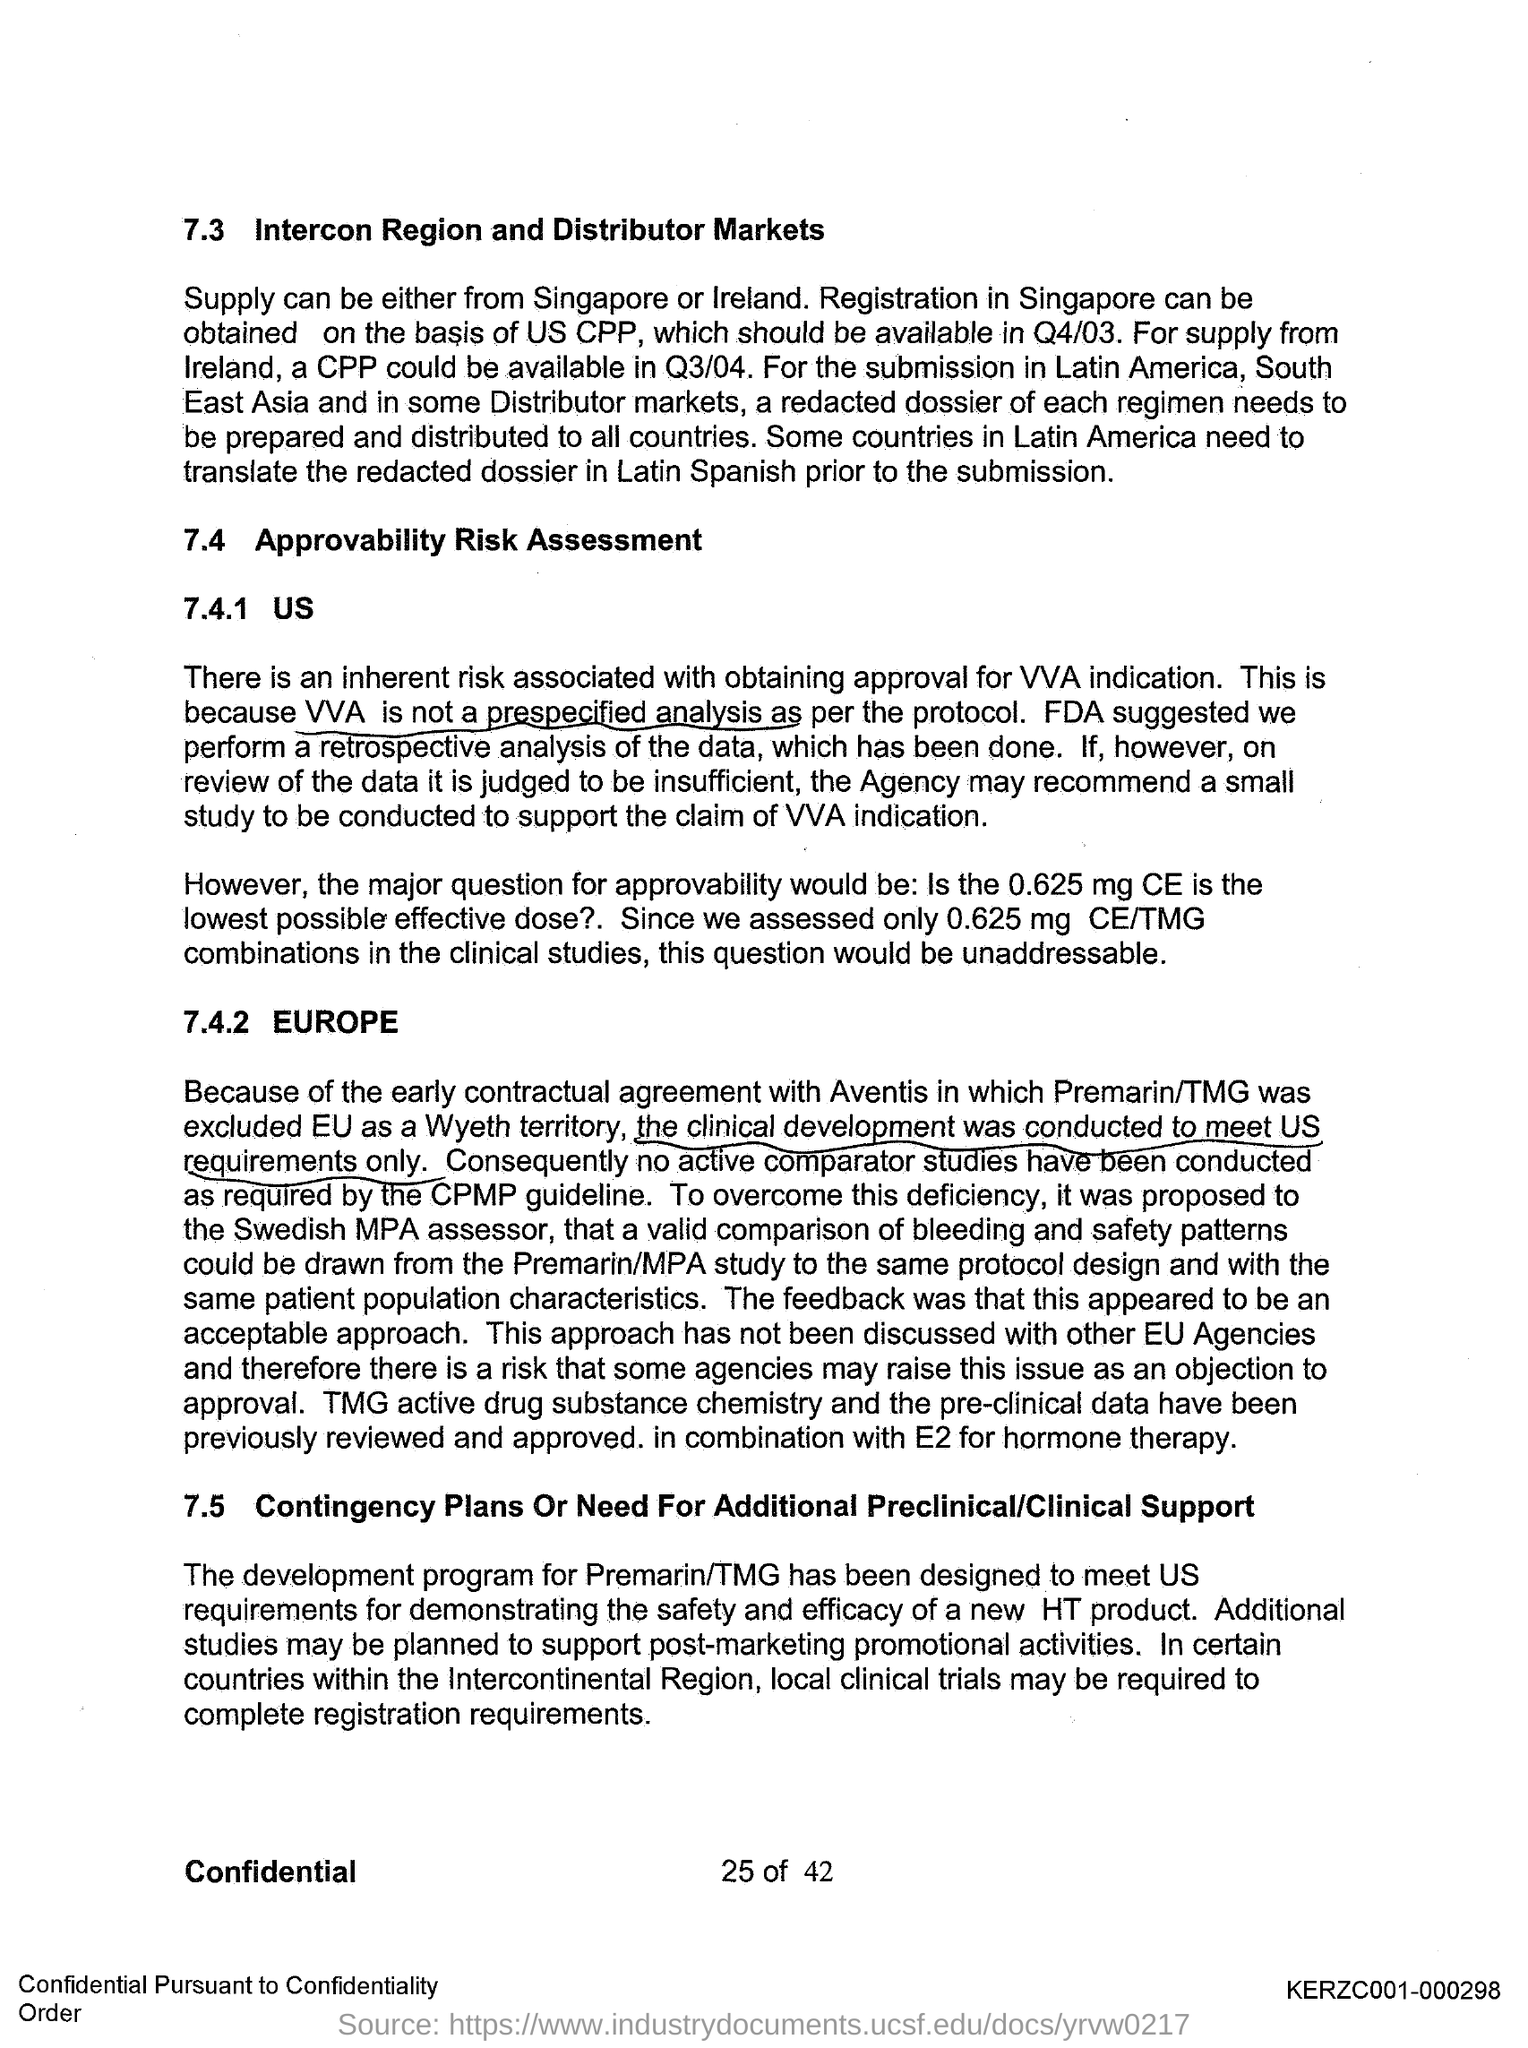What is the first title in the document?
Provide a succinct answer. Intercon Region and Distributor Markets. 